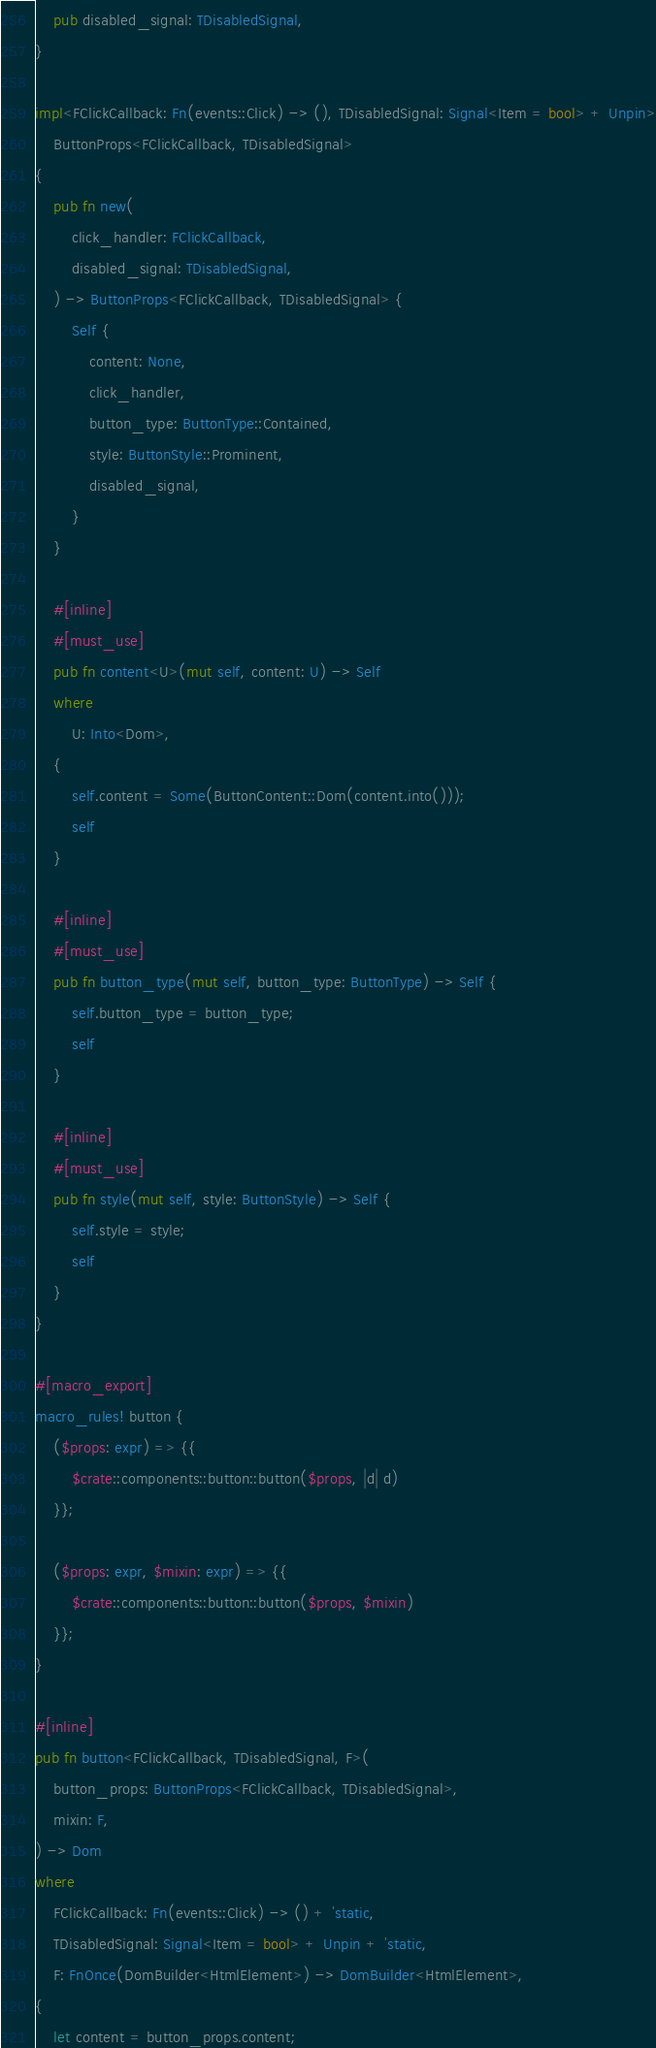<code> <loc_0><loc_0><loc_500><loc_500><_Rust_>    pub disabled_signal: TDisabledSignal,
}

impl<FClickCallback: Fn(events::Click) -> (), TDisabledSignal: Signal<Item = bool> + Unpin>
    ButtonProps<FClickCallback, TDisabledSignal>
{
    pub fn new(
        click_handler: FClickCallback,
        disabled_signal: TDisabledSignal,
    ) -> ButtonProps<FClickCallback, TDisabledSignal> {
        Self {
            content: None,
            click_handler,
            button_type: ButtonType::Contained,
            style: ButtonStyle::Prominent,
            disabled_signal,
        }
    }

    #[inline]
    #[must_use]
    pub fn content<U>(mut self, content: U) -> Self
    where
        U: Into<Dom>,
    {
        self.content = Some(ButtonContent::Dom(content.into()));
        self
    }

    #[inline]
    #[must_use]
    pub fn button_type(mut self, button_type: ButtonType) -> Self {
        self.button_type = button_type;
        self
    }

    #[inline]
    #[must_use]
    pub fn style(mut self, style: ButtonStyle) -> Self {
        self.style = style;
        self
    }
}

#[macro_export]
macro_rules! button {
    ($props: expr) => {{
        $crate::components::button::button($props, |d| d)
    }};

    ($props: expr, $mixin: expr) => {{
        $crate::components::button::button($props, $mixin)
    }};
}

#[inline]
pub fn button<FClickCallback, TDisabledSignal, F>(
    button_props: ButtonProps<FClickCallback, TDisabledSignal>,
    mixin: F,
) -> Dom
where
    FClickCallback: Fn(events::Click) -> () + 'static,
    TDisabledSignal: Signal<Item = bool> + Unpin + 'static,
    F: FnOnce(DomBuilder<HtmlElement>) -> DomBuilder<HtmlElement>,
{
    let content = button_props.content;</code> 